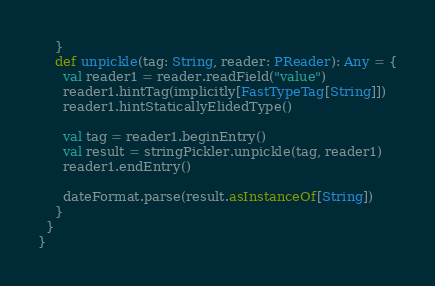Convert code to text. <code><loc_0><loc_0><loc_500><loc_500><_Scala_>    }
    def unpickle(tag: String, reader: PReader): Any = {
      val reader1 = reader.readField("value")
      reader1.hintTag(implicitly[FastTypeTag[String]])
      reader1.hintStaticallyElidedType()

      val tag = reader1.beginEntry()
      val result = stringPickler.unpickle(tag, reader1)
      reader1.endEntry()

      dateFormat.parse(result.asInstanceOf[String])
    }
  }
}
</code> 